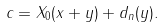<formula> <loc_0><loc_0><loc_500><loc_500>c = X _ { 0 } ( x + y ) + d _ { n } ( y ) .</formula> 